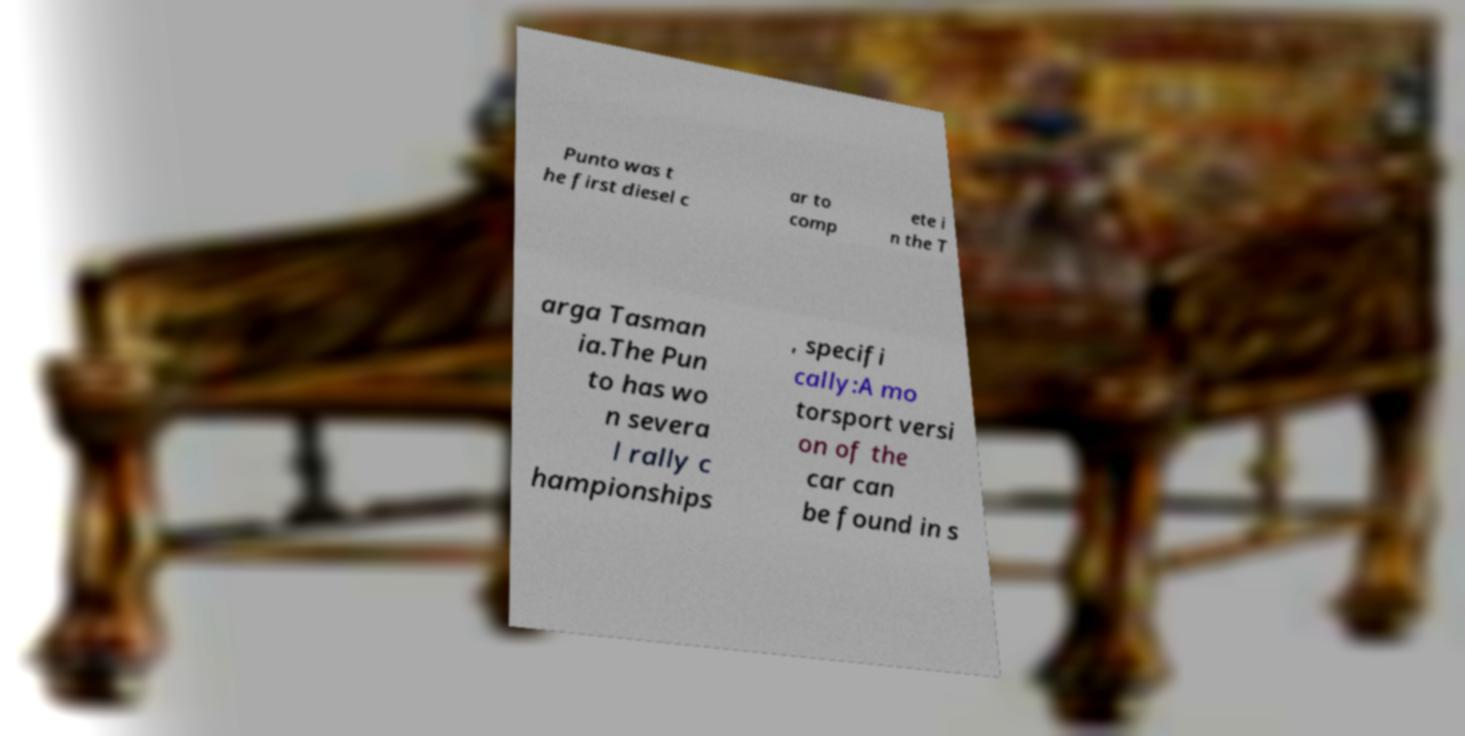For documentation purposes, I need the text within this image transcribed. Could you provide that? Punto was t he first diesel c ar to comp ete i n the T arga Tasman ia.The Pun to has wo n severa l rally c hampionships , specifi cally:A mo torsport versi on of the car can be found in s 